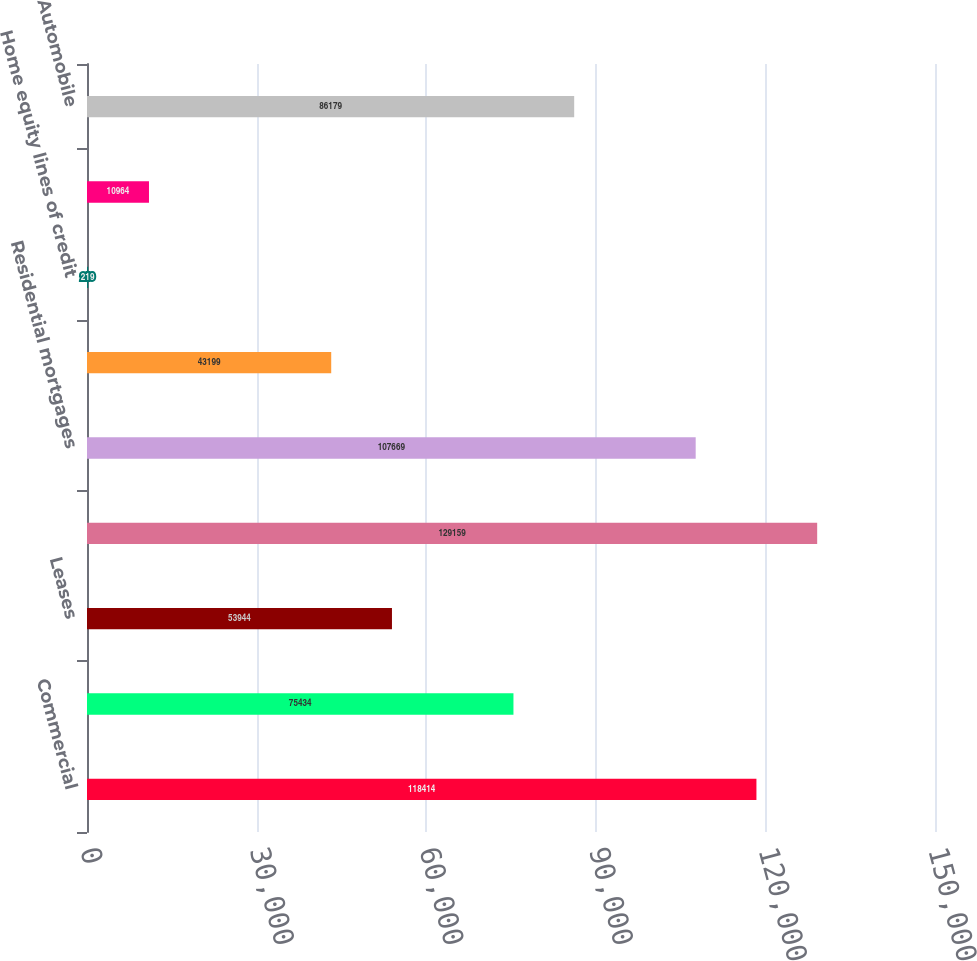Convert chart to OTSL. <chart><loc_0><loc_0><loc_500><loc_500><bar_chart><fcel>Commercial<fcel>Commercial real estate<fcel>Leases<fcel>Total commercial<fcel>Residential mortgages<fcel>Home equity loans<fcel>Home equity lines of credit<fcel>Home equity loans serviced by<fcel>Automobile<nl><fcel>118414<fcel>75434<fcel>53944<fcel>129159<fcel>107669<fcel>43199<fcel>219<fcel>10964<fcel>86179<nl></chart> 